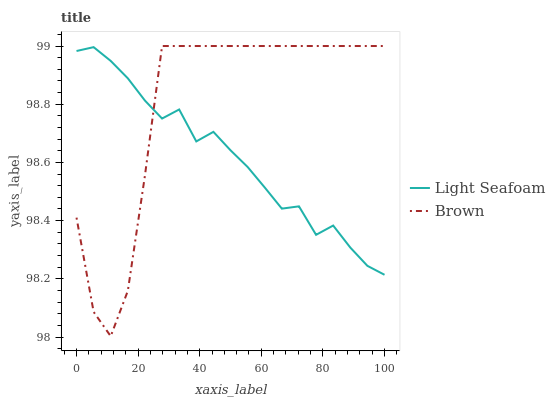Does Light Seafoam have the minimum area under the curve?
Answer yes or no. Yes. Does Brown have the maximum area under the curve?
Answer yes or no. Yes. Does Light Seafoam have the maximum area under the curve?
Answer yes or no. No. Is Light Seafoam the smoothest?
Answer yes or no. Yes. Is Brown the roughest?
Answer yes or no. Yes. Is Light Seafoam the roughest?
Answer yes or no. No. Does Brown have the lowest value?
Answer yes or no. Yes. Does Light Seafoam have the lowest value?
Answer yes or no. No. Does Brown have the highest value?
Answer yes or no. Yes. Does Light Seafoam have the highest value?
Answer yes or no. No. Does Light Seafoam intersect Brown?
Answer yes or no. Yes. Is Light Seafoam less than Brown?
Answer yes or no. No. Is Light Seafoam greater than Brown?
Answer yes or no. No. 